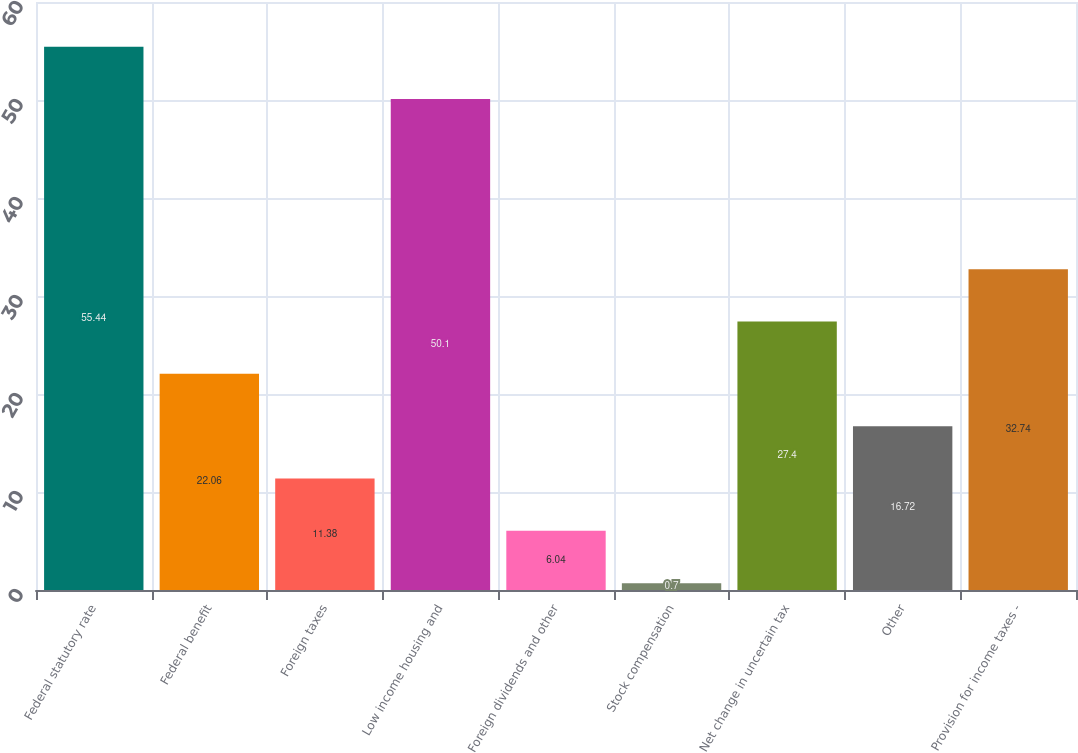<chart> <loc_0><loc_0><loc_500><loc_500><bar_chart><fcel>Federal statutory rate<fcel>Federal benefit<fcel>Foreign taxes<fcel>Low income housing and<fcel>Foreign dividends and other<fcel>Stock compensation<fcel>Net change in uncertain tax<fcel>Other<fcel>Provision for income taxes -<nl><fcel>55.44<fcel>22.06<fcel>11.38<fcel>50.1<fcel>6.04<fcel>0.7<fcel>27.4<fcel>16.72<fcel>32.74<nl></chart> 